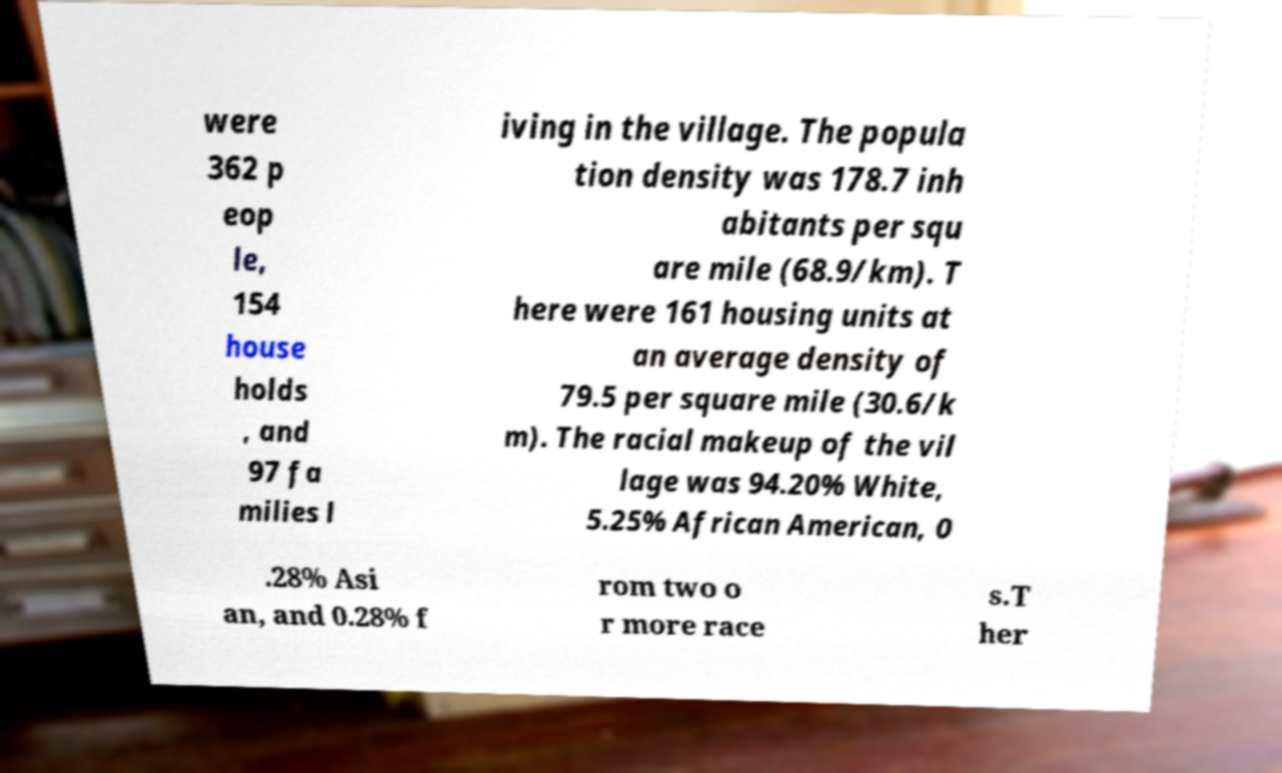For documentation purposes, I need the text within this image transcribed. Could you provide that? were 362 p eop le, 154 house holds , and 97 fa milies l iving in the village. The popula tion density was 178.7 inh abitants per squ are mile (68.9/km). T here were 161 housing units at an average density of 79.5 per square mile (30.6/k m). The racial makeup of the vil lage was 94.20% White, 5.25% African American, 0 .28% Asi an, and 0.28% f rom two o r more race s.T her 